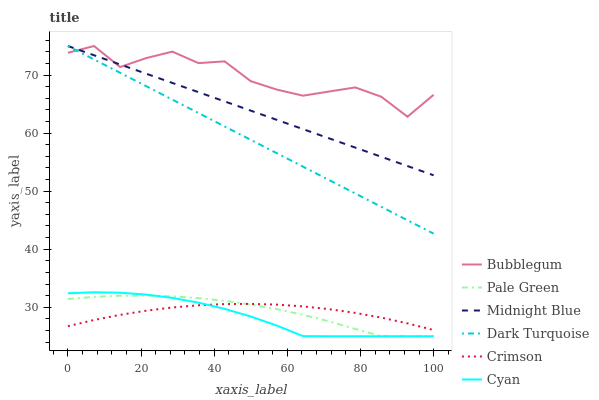Does Dark Turquoise have the minimum area under the curve?
Answer yes or no. No. Does Dark Turquoise have the maximum area under the curve?
Answer yes or no. No. Is Bubblegum the smoothest?
Answer yes or no. No. Is Dark Turquoise the roughest?
Answer yes or no. No. Does Dark Turquoise have the lowest value?
Answer yes or no. No. Does Pale Green have the highest value?
Answer yes or no. No. Is Crimson less than Bubblegum?
Answer yes or no. Yes. Is Bubblegum greater than Crimson?
Answer yes or no. Yes. Does Crimson intersect Bubblegum?
Answer yes or no. No. 